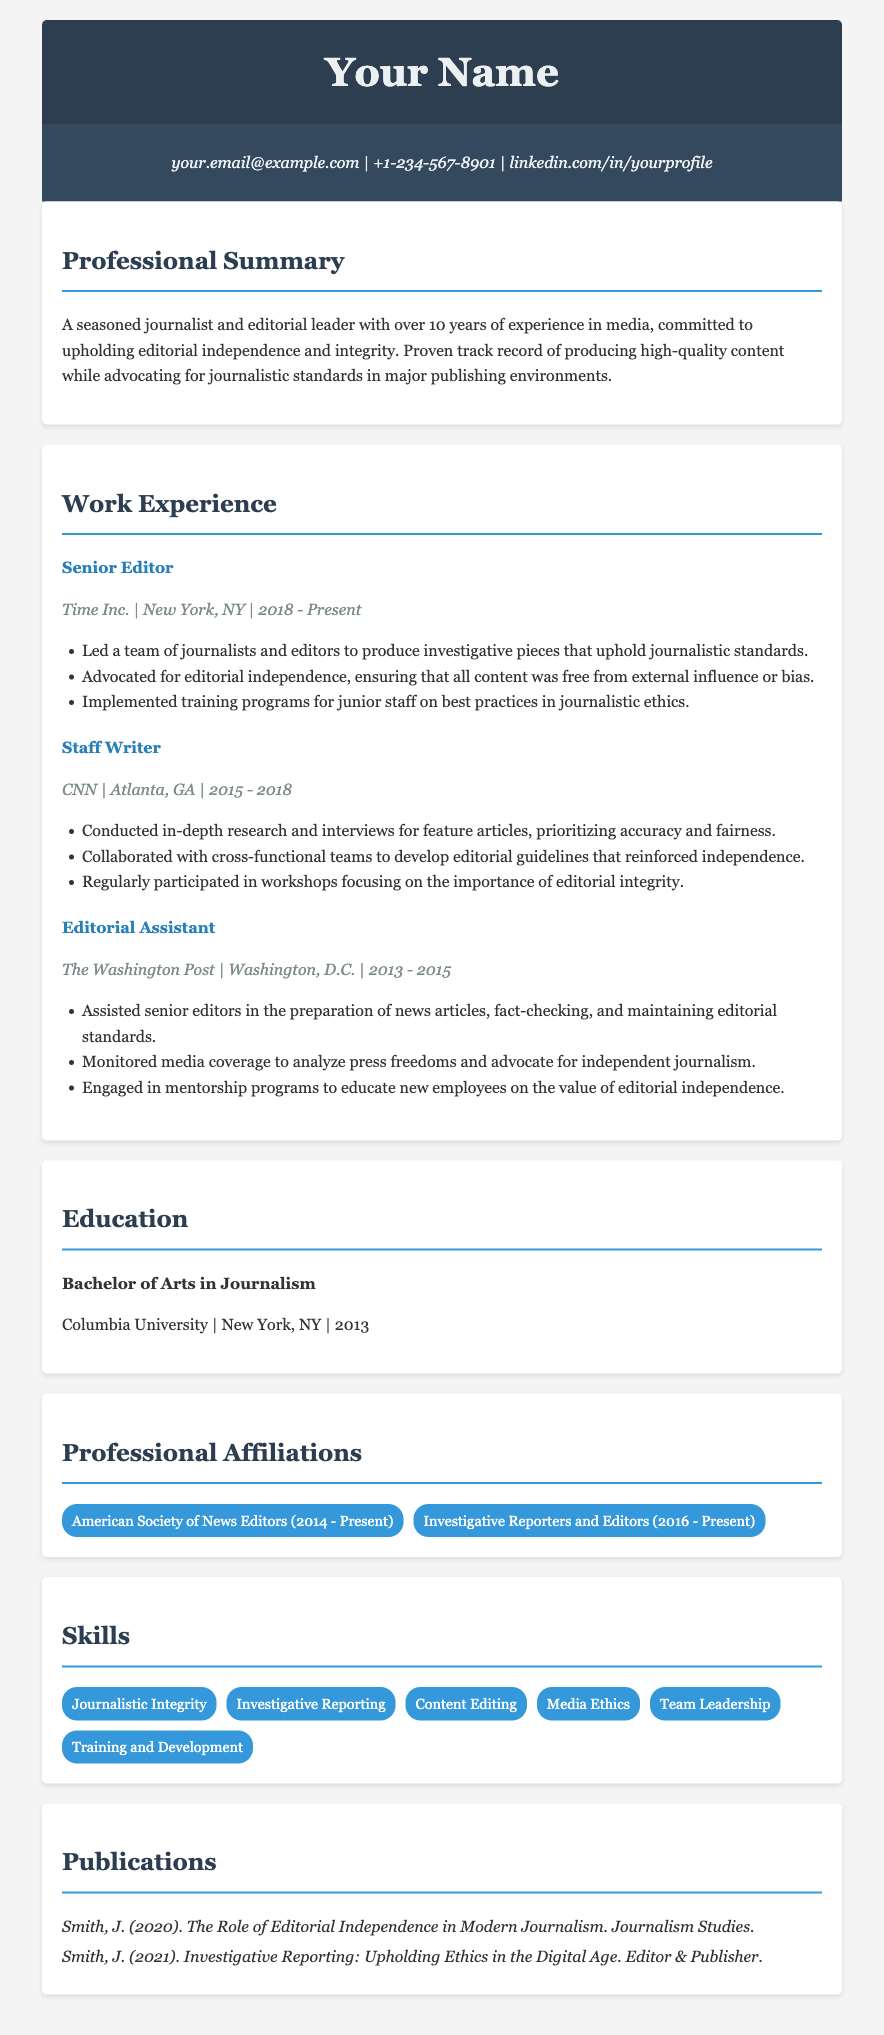what is the current job title? The job title listed in the document is the most recent one mentioned, which is "Senior Editor."
Answer: Senior Editor what is the name of the first organization listed in the work experience? The first organization listed in the work experience section is where the individual worked as a Senior Editor, which is Time Inc.
Answer: Time Inc how many years of experience does the individual have in journalism? The document states that the individual has over 10 years of experience in media, which includes journalism.
Answer: over 10 years which university did the individual attend? The education section mentions a Bachelor's degree in Journalism from a specific university, which is Columbia University.
Answer: Columbia University what is one of the skills listed in the skills section? The skills section includes various skills, and one of them is "Investigative Reporting."
Answer: Investigative Reporting how many professional affiliations does the individual have? The document lists two affiliations under professional affiliations, giving the total count.
Answer: 2 what is the title of one of the publications mentioned? The publications section provides a list of titles, one of which is "The Role of Editorial Independence in Modern Journalism."
Answer: The Role of Editorial Independence in Modern Journalism what years did the individual work at CNN? The work experience section specifies the time frame of employment at CNN.
Answer: 2015 - 2018 what is the location of The Washington Post? The location of The Washington Post, as stated in the work experience section, is Washington, D.C.
Answer: Washington, D.C 